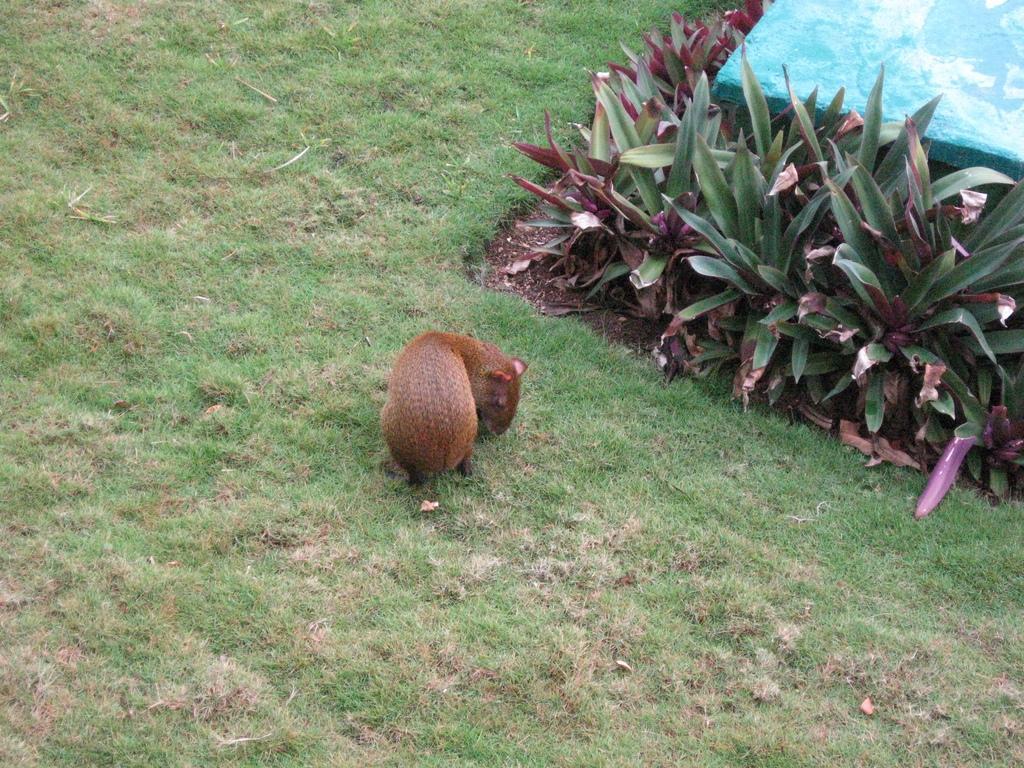Can you describe this image briefly? This picture is taken from the outside of the city. In this image, in the middle, we can see an animal. On the right side, we can see some plants. In the right corner, we can also see a blue color object. In the background, we can see a grass. 